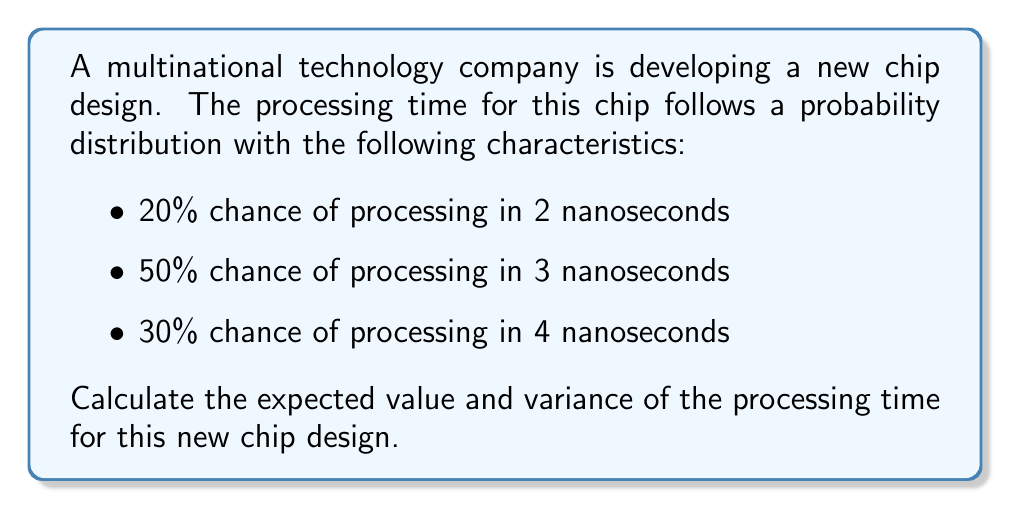What is the answer to this math problem? To solve this problem, we'll follow these steps:

1. Calculate the expected value (E[X])
2. Calculate the variance (Var(X))

Step 1: Expected Value (E[X])

The expected value is the sum of each possible outcome multiplied by its probability:

$$E[X] = \sum_{i=1}^{n} x_i \cdot p(x_i)$$

Where $x_i$ are the possible outcomes and $p(x_i)$ are their respective probabilities.

$$E[X] = 2 \cdot 0.20 + 3 \cdot 0.50 + 4 \cdot 0.30$$
$$E[X] = 0.40 + 1.50 + 1.20 = 3.10$$

Step 2: Variance (Var(X))

The variance is the expected value of the squared difference between the random variable and its mean:

$$Var(X) = E[(X - \mu)^2] = E[X^2] - (E[X])^2$$

First, we need to calculate $E[X^2]$:

$$E[X^2] = \sum_{i=1}^{n} x_i^2 \cdot p(x_i)$$

$$E[X^2] = 2^2 \cdot 0.20 + 3^2 \cdot 0.50 + 4^2 \cdot 0.30$$
$$E[X^2] = 4 \cdot 0.20 + 9 \cdot 0.50 + 16 \cdot 0.30$$
$$E[X^2] = 0.80 + 4.50 + 4.80 = 10.10$$

Now we can calculate the variance:

$$Var(X) = E[X^2] - (E[X])^2$$
$$Var(X) = 10.10 - (3.10)^2$$
$$Var(X) = 10.10 - 9.61 = 0.49$$
Answer: Expected Value (E[X]) = 3.10 nanoseconds
Variance (Var(X)) = 0.49 nanoseconds^2 